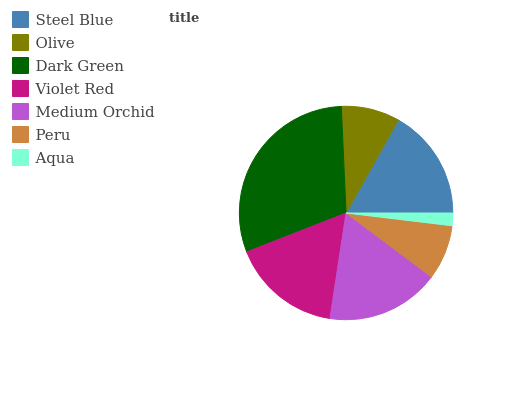Is Aqua the minimum?
Answer yes or no. Yes. Is Dark Green the maximum?
Answer yes or no. Yes. Is Olive the minimum?
Answer yes or no. No. Is Olive the maximum?
Answer yes or no. No. Is Steel Blue greater than Olive?
Answer yes or no. Yes. Is Olive less than Steel Blue?
Answer yes or no. Yes. Is Olive greater than Steel Blue?
Answer yes or no. No. Is Steel Blue less than Olive?
Answer yes or no. No. Is Violet Red the high median?
Answer yes or no. Yes. Is Violet Red the low median?
Answer yes or no. Yes. Is Steel Blue the high median?
Answer yes or no. No. Is Aqua the low median?
Answer yes or no. No. 